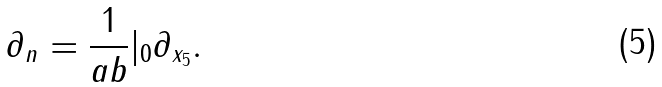Convert formula to latex. <formula><loc_0><loc_0><loc_500><loc_500>\partial _ { n } = \frac { 1 } { a b } | _ { 0 } \partial _ { x _ { 5 } } .</formula> 